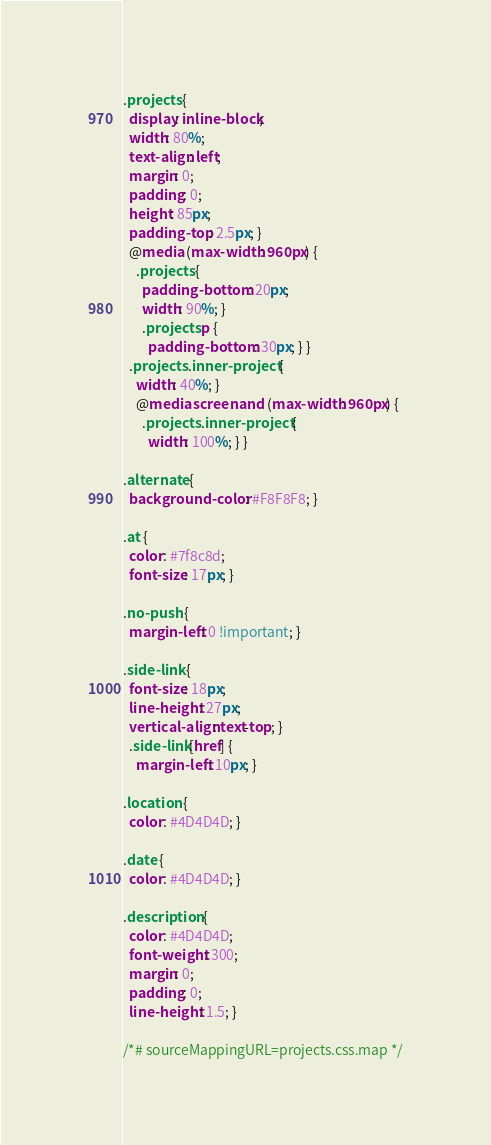<code> <loc_0><loc_0><loc_500><loc_500><_CSS_>.projects {
  display: inline-block;
  width: 80%;
  text-align: left;
  margin: 0;
  padding: 0;
  height: 85px;
  padding-top: 2.5px; }
  @media (max-width: 960px) {
    .projects {
      padding-bottom: 20px;
      width: 90%; }
      .projects p {
        padding-bottom: 30px; } }
  .projects .inner-project {
    width: 40%; }
    @media screen and (max-width: 960px) {
      .projects .inner-project {
        width: 100%; } }

.alternate {
  background-color: #F8F8F8; }

.at {
  color: #7f8c8d;
  font-size: 17px; }

.no-push {
  margin-left: 0 !important; }

.side-link {
  font-size: 18px;
  line-height: 27px;
  vertical-align: text-top; }
  .side-link[href] {
    margin-left: 10px; }

.location {
  color: #4D4D4D; }

.date {
  color: #4D4D4D; }

.description {
  color: #4D4D4D;
  font-weight: 300;
  margin: 0;
  padding: 0;
  line-height: 1.5; }

/*# sourceMappingURL=projects.css.map */
</code> 